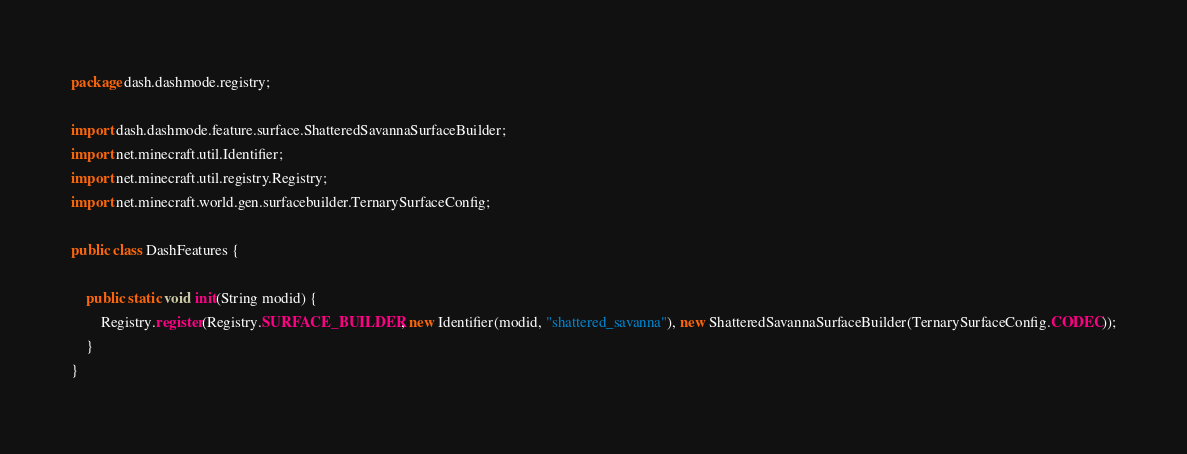Convert code to text. <code><loc_0><loc_0><loc_500><loc_500><_Java_>package dash.dashmode.registry;

import dash.dashmode.feature.surface.ShatteredSavannaSurfaceBuilder;
import net.minecraft.util.Identifier;
import net.minecraft.util.registry.Registry;
import net.minecraft.world.gen.surfacebuilder.TernarySurfaceConfig;

public class DashFeatures {

    public static void init(String modid) {
        Registry.register(Registry.SURFACE_BUILDER, new Identifier(modid, "shattered_savanna"), new ShatteredSavannaSurfaceBuilder(TernarySurfaceConfig.CODEC));
    }
}
</code> 